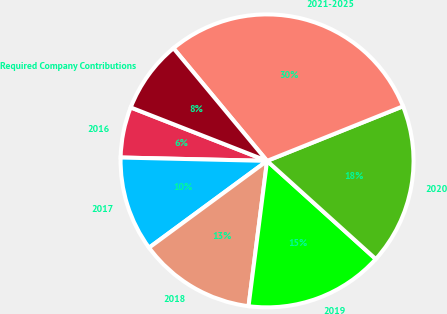Convert chart to OTSL. <chart><loc_0><loc_0><loc_500><loc_500><pie_chart><fcel>2016<fcel>2017<fcel>2018<fcel>2019<fcel>2020<fcel>2021-2025<fcel>Required Company Contributions<nl><fcel>5.58%<fcel>10.46%<fcel>12.89%<fcel>15.33%<fcel>17.77%<fcel>29.96%<fcel>8.02%<nl></chart> 